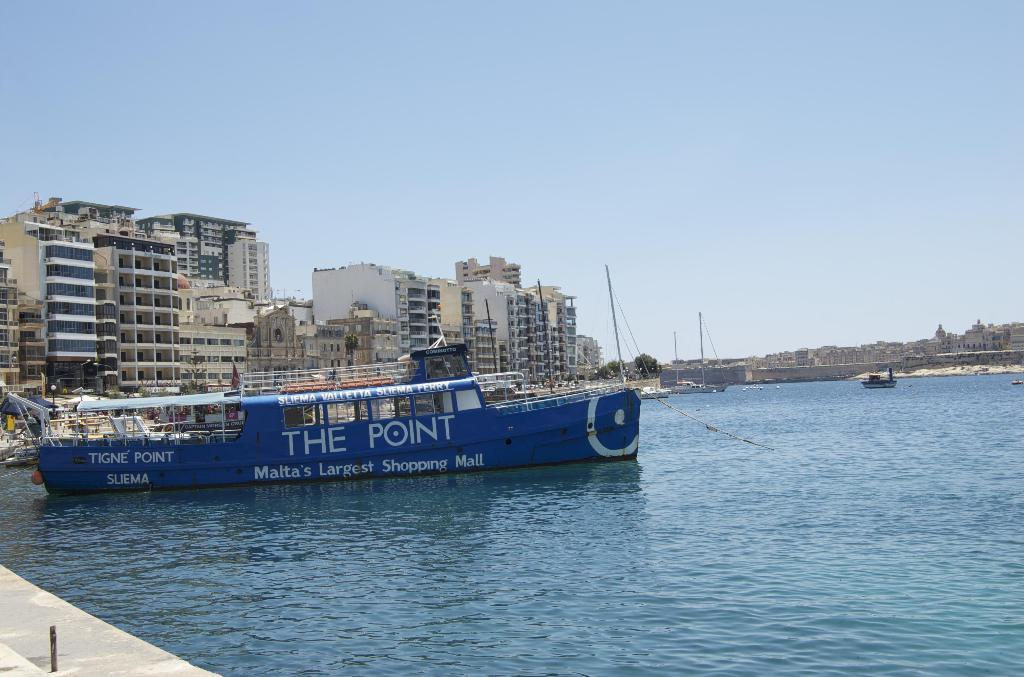<image>
Create a compact narrative representing the image presented. A ferry from Tigne Point is docked in a bay. 